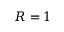Convert formula to latex. <formula><loc_0><loc_0><loc_500><loc_500>R = 1</formula> 